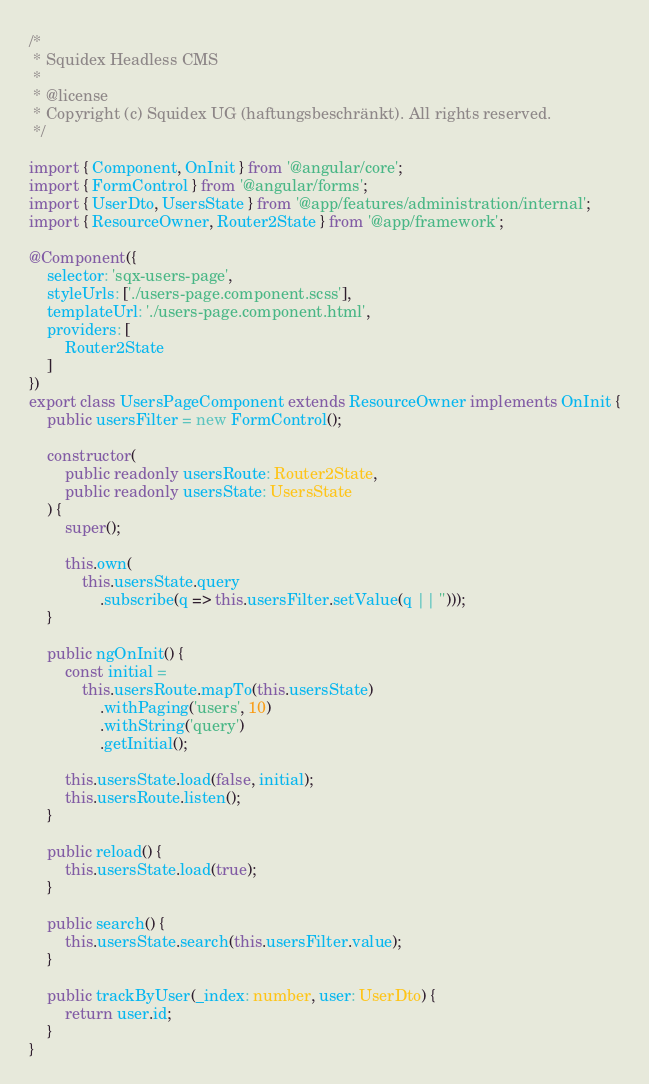Convert code to text. <code><loc_0><loc_0><loc_500><loc_500><_TypeScript_>/*
 * Squidex Headless CMS
 *
 * @license
 * Copyright (c) Squidex UG (haftungsbeschränkt). All rights reserved.
 */

import { Component, OnInit } from '@angular/core';
import { FormControl } from '@angular/forms';
import { UserDto, UsersState } from '@app/features/administration/internal';
import { ResourceOwner, Router2State } from '@app/framework';

@Component({
    selector: 'sqx-users-page',
    styleUrls: ['./users-page.component.scss'],
    templateUrl: './users-page.component.html',
    providers: [
        Router2State
    ]
})
export class UsersPageComponent extends ResourceOwner implements OnInit {
    public usersFilter = new FormControl();

    constructor(
        public readonly usersRoute: Router2State,
        public readonly usersState: UsersState
    ) {
        super();

        this.own(
            this.usersState.query
                .subscribe(q => this.usersFilter.setValue(q || '')));
    }

    public ngOnInit() {
        const initial =
            this.usersRoute.mapTo(this.usersState)
                .withPaging('users', 10)
                .withString('query')
                .getInitial();

        this.usersState.load(false, initial);
        this.usersRoute.listen();
    }

    public reload() {
        this.usersState.load(true);
    }

    public search() {
        this.usersState.search(this.usersFilter.value);
    }

    public trackByUser(_index: number, user: UserDto) {
        return user.id;
    }
}</code> 